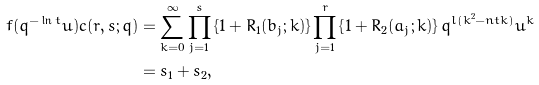<formula> <loc_0><loc_0><loc_500><loc_500>f ( q ^ { - \ln t } u ) c ( r , s ; q ) & = \sum _ { k = 0 } ^ { \infty } \prod _ { j = 1 } ^ { s } \left \{ { 1 + R } _ { 1 } ( b _ { j } ; k ) \right \} \prod _ { j = 1 } ^ { r } \left \{ 1 + R _ { 2 } ( a _ { j } ; k ) \right \} q ^ { l ( k ^ { 2 } - n t k ) } u ^ { k } \\ & = s _ { 1 } + s _ { 2 } ,</formula> 